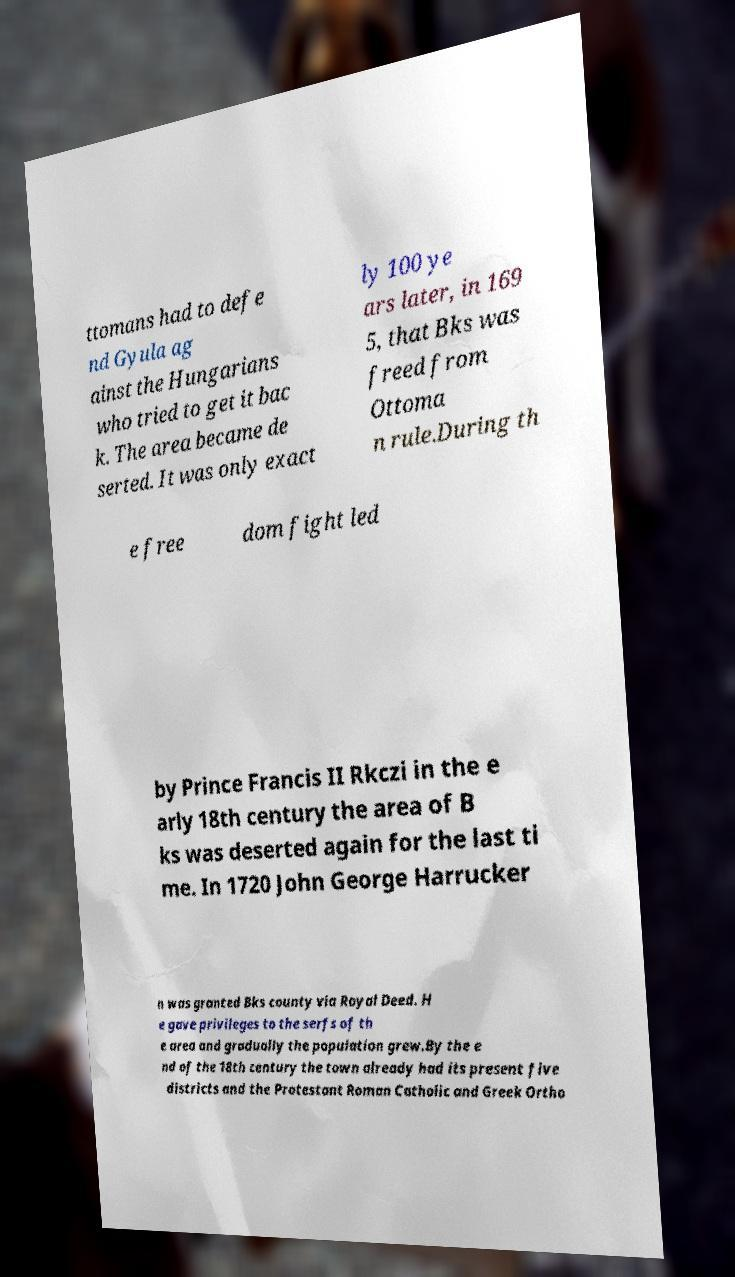Can you accurately transcribe the text from the provided image for me? ttomans had to defe nd Gyula ag ainst the Hungarians who tried to get it bac k. The area became de serted. It was only exact ly 100 ye ars later, in 169 5, that Bks was freed from Ottoma n rule.During th e free dom fight led by Prince Francis II Rkczi in the e arly 18th century the area of B ks was deserted again for the last ti me. In 1720 John George Harrucker n was granted Bks county via Royal Deed. H e gave privileges to the serfs of th e area and gradually the population grew.By the e nd of the 18th century the town already had its present five districts and the Protestant Roman Catholic and Greek Ortho 